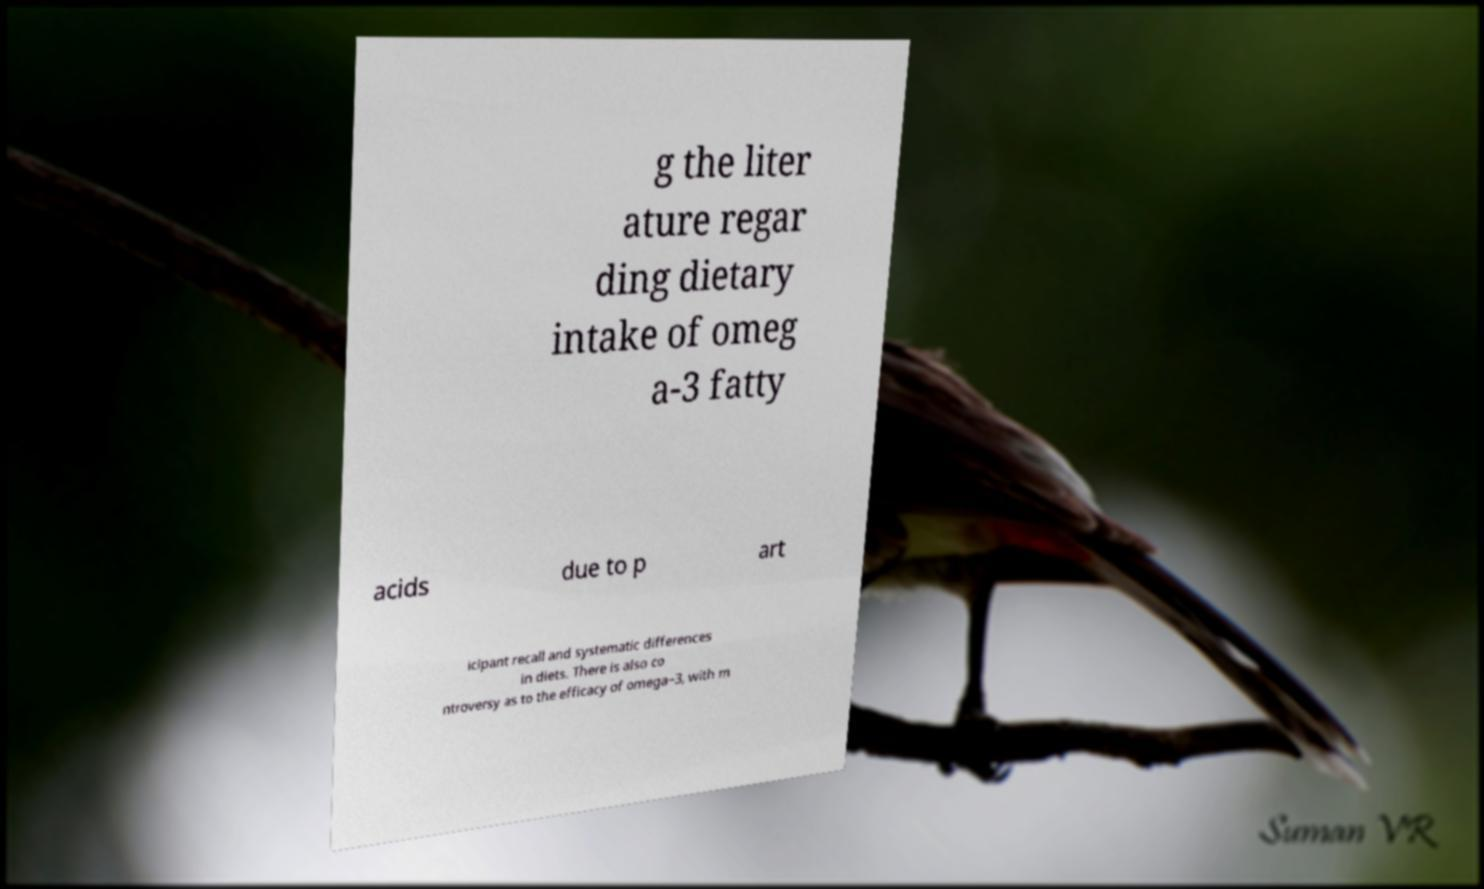Could you assist in decoding the text presented in this image and type it out clearly? g the liter ature regar ding dietary intake of omeg a-3 fatty acids due to p art icipant recall and systematic differences in diets. There is also co ntroversy as to the efficacy of omega−3, with m 